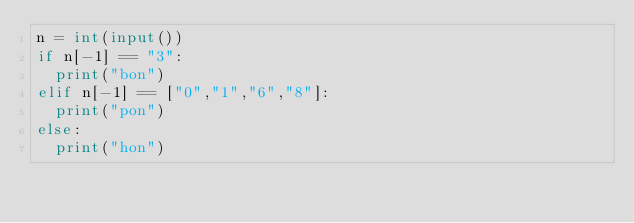<code> <loc_0><loc_0><loc_500><loc_500><_Python_>n = int(input())
if n[-1] == "3":
  print("bon")
elif n[-1] == ["0","1","6","8"]:
  print("pon")
else:
  print("hon")</code> 